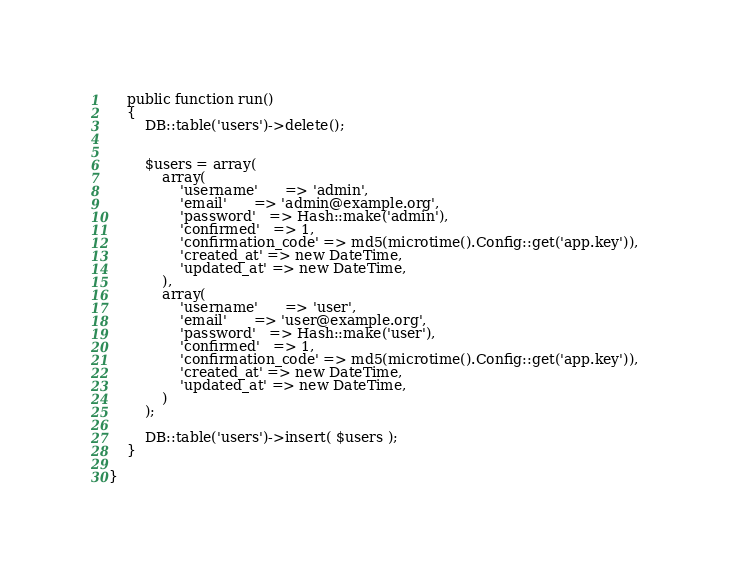Convert code to text. <code><loc_0><loc_0><loc_500><loc_500><_PHP_>
    public function run()
    {
        DB::table('users')->delete();


        $users = array(
            array(
                'username'      => 'admin',
                'email'      => 'admin@example.org',
                'password'   => Hash::make('admin'),
                'confirmed'   => 1,
                'confirmation_code' => md5(microtime().Config::get('app.key')),
                'created_at' => new DateTime,
                'updated_at' => new DateTime,
            ),
            array(
                'username'      => 'user',
                'email'      => 'user@example.org',
                'password'   => Hash::make('user'),
                'confirmed'   => 1,
                'confirmation_code' => md5(microtime().Config::get('app.key')),
                'created_at' => new DateTime,
                'updated_at' => new DateTime,
            )
        );

        DB::table('users')->insert( $users );
    }

}
</code> 